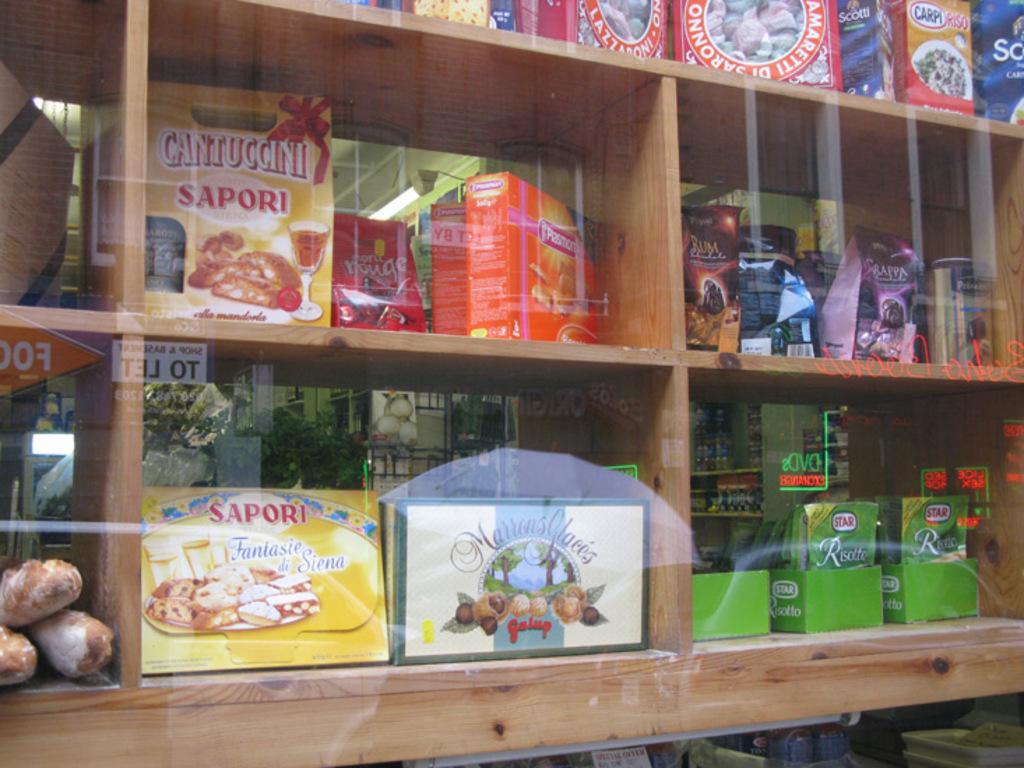How would you summarize this image in a sentence or two? In this picture we can see a glass in the front, from the glass we can see shelves, there are some boxes and packets placed on these shelves, in the background we can see a plant. 